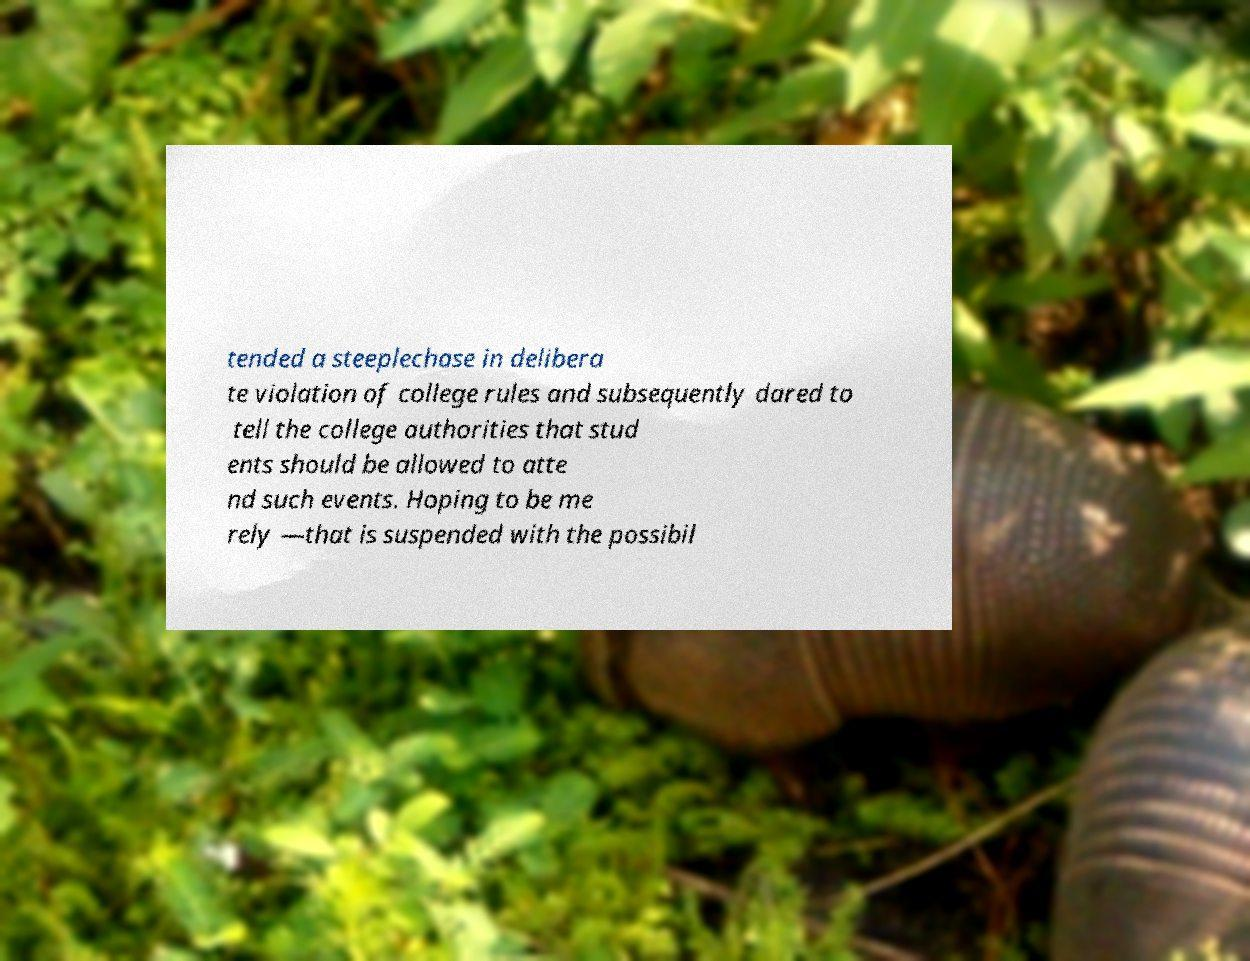Could you assist in decoding the text presented in this image and type it out clearly? tended a steeplechase in delibera te violation of college rules and subsequently dared to tell the college authorities that stud ents should be allowed to atte nd such events. Hoping to be me rely —that is suspended with the possibil 